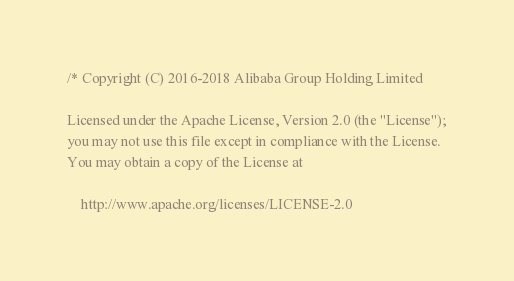Convert code to text. <code><loc_0><loc_0><loc_500><loc_500><_C_>/* Copyright (C) 2016-2018 Alibaba Group Holding Limited

Licensed under the Apache License, Version 2.0 (the "License");
you may not use this file except in compliance with the License.
You may obtain a copy of the License at

    http://www.apache.org/licenses/LICENSE-2.0
</code> 